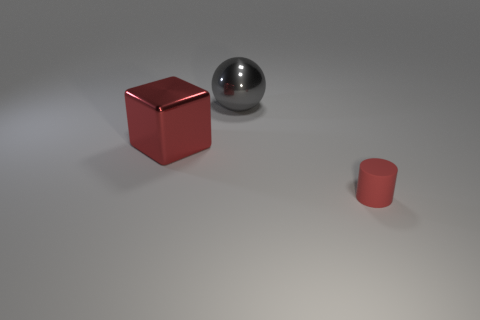Add 1 big blue rubber cylinders. How many objects exist? 4 Subtract all cubes. How many objects are left? 2 Subtract all big balls. Subtract all rubber cylinders. How many objects are left? 1 Add 2 gray spheres. How many gray spheres are left? 3 Add 2 gray spheres. How many gray spheres exist? 3 Subtract 0 green balls. How many objects are left? 3 